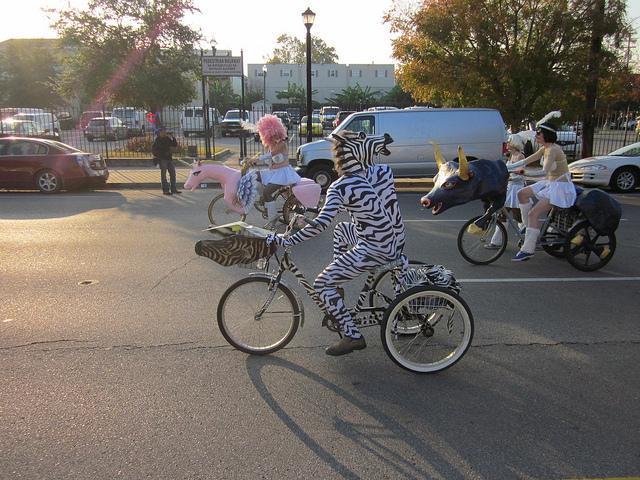How many bicycles can be seen?
Give a very brief answer. 3. How many trucks can you see?
Give a very brief answer. 1. How many people are visible?
Give a very brief answer. 3. How many cars are there?
Give a very brief answer. 3. How many buses are pictured?
Give a very brief answer. 0. 